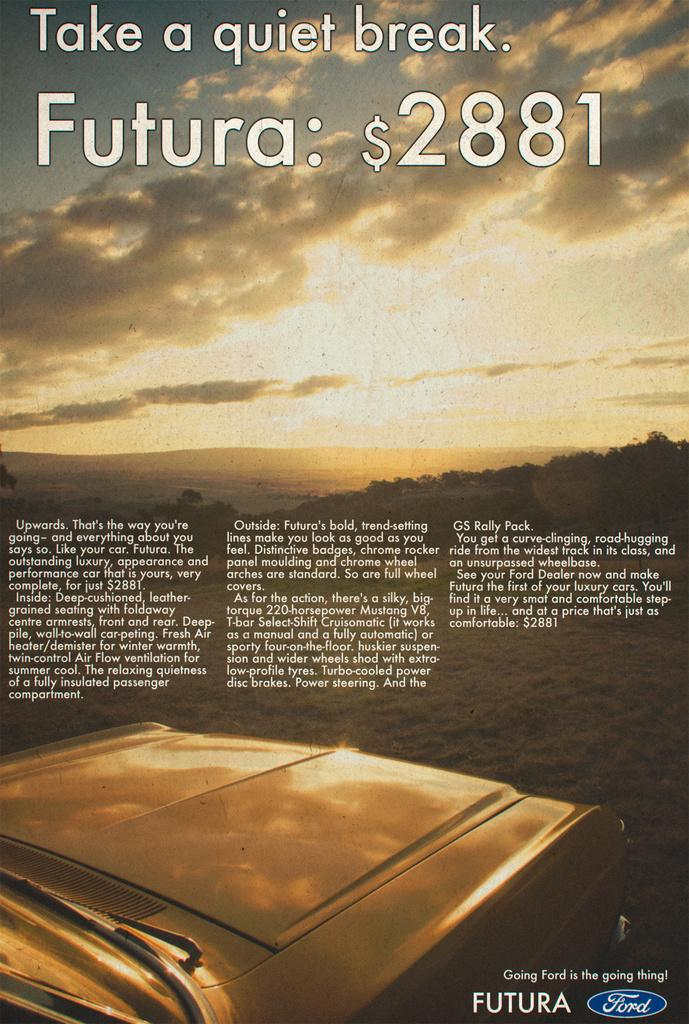Provide a one-sentence caption for the provided image. A Ford advertisement for the Futura shows it starts at $2881.00. 